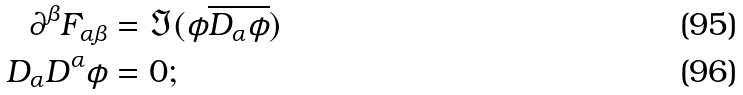<formula> <loc_0><loc_0><loc_500><loc_500>\partial ^ { \beta } F _ { \alpha \beta } & = \Im ( \phi \overline { D _ { \alpha } \phi } ) \\ D _ { \alpha } D ^ { \alpha } \phi & = 0 ;</formula> 